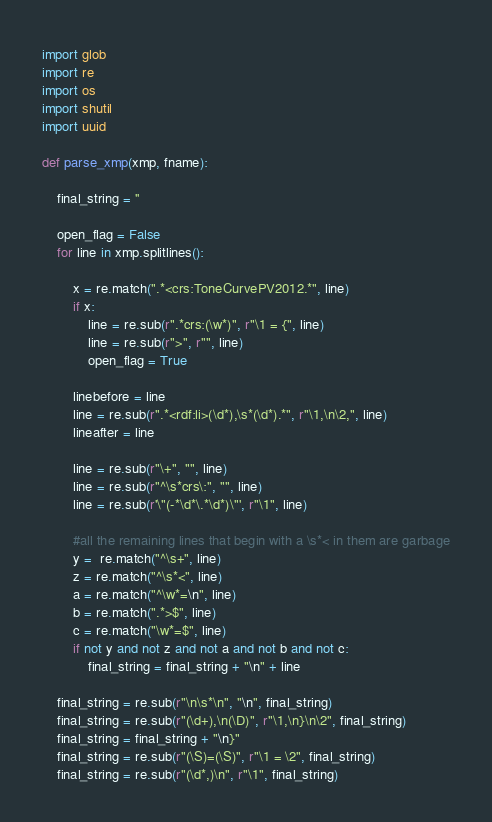Convert code to text. <code><loc_0><loc_0><loc_500><loc_500><_Python_>import glob
import re
import os
import shutil
import uuid

def parse_xmp(xmp, fname):

    final_string = ''

    open_flag = False
    for line in xmp.splitlines():

        x = re.match(".*<crs:ToneCurvePV2012.*", line)
        if x:
            line = re.sub(r".*crs:(\w*)", r"\1 = {", line)
            line = re.sub(r">", r"", line)
            open_flag = True

        linebefore = line
        line = re.sub(r".*<rdf:li>(\d*),\s*(\d*).*", r"\1,\n\2,", line)
        lineafter = line

        line = re.sub(r"\+", "", line)
        line = re.sub(r"^\s*crs\:", "", line)
        line = re.sub(r'\"(-*\d*\.*\d*)\"', r"\1", line)

        #all the remaining lines that begin with a \s*< in them are garbage
        y =  re.match("^\s+", line)
        z = re.match("^\s*<", line)
        a = re.match("^\w*=\n", line)
        b = re.match(".*>$", line)
        c = re.match("\w*=$", line)
        if not y and not z and not a and not b and not c:
            final_string = final_string + "\n" + line

    final_string = re.sub(r"\n\s*\n", "\n", final_string)    
    final_string = re.sub(r"(\d+),\n(\D)", r"\1,\n}\n\2", final_string)    
    final_string = final_string + "\n}"
    final_string = re.sub(r"(\S)=(\S)", r"\1 = \2", final_string)    
    final_string = re.sub(r"(\d*,)\n", r"\1", final_string)    </code> 